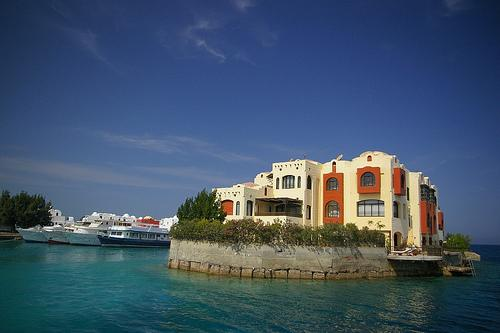What is the house near?

Choices:
A) baby
B) cat
C) water
D) dog water 